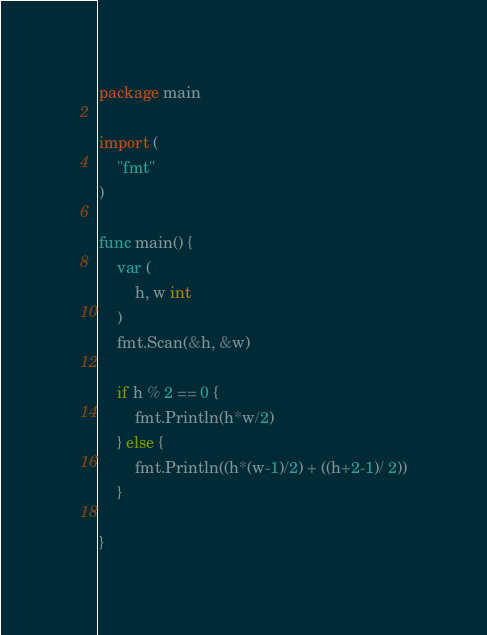<code> <loc_0><loc_0><loc_500><loc_500><_Go_>package main

import (
	"fmt"
)

func main() {
	var (
		h, w int
	)
	fmt.Scan(&h, &w)

	if h % 2 == 0 {
		fmt.Println(h*w/2)
	} else {
		fmt.Println((h*(w-1)/2) + ((h+2-1)/ 2))
	}

}
</code> 